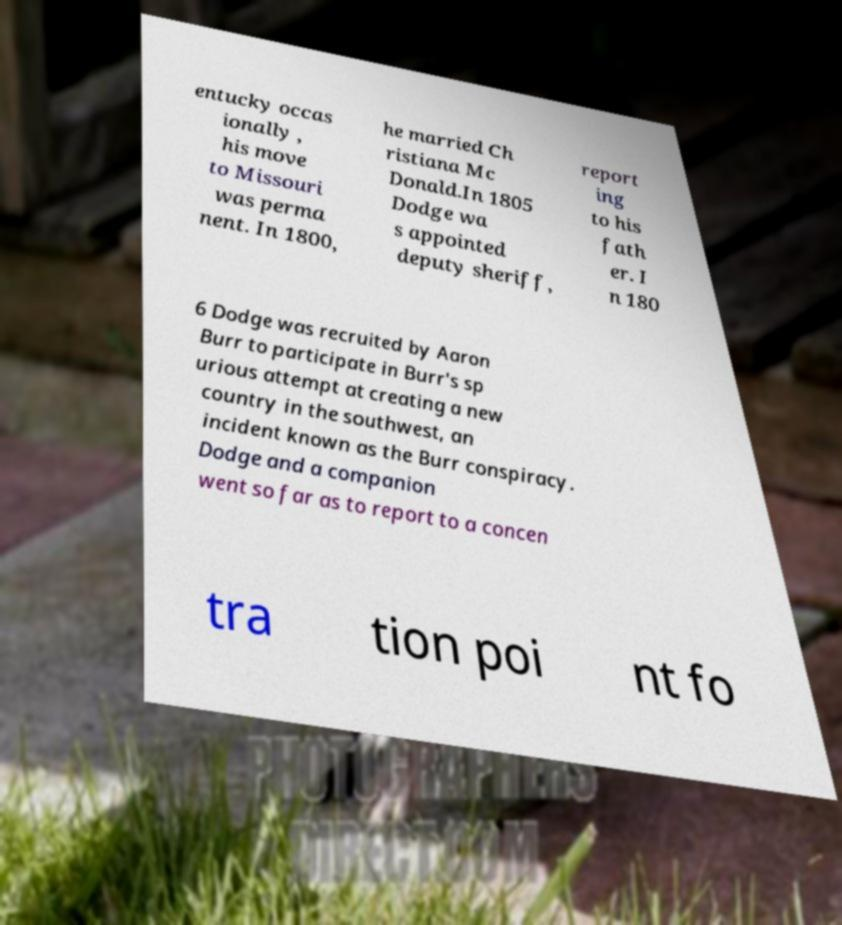Please read and relay the text visible in this image. What does it say? entucky occas ionally , his move to Missouri was perma nent. In 1800, he married Ch ristiana Mc Donald.In 1805 Dodge wa s appointed deputy sheriff, report ing to his fath er. I n 180 6 Dodge was recruited by Aaron Burr to participate in Burr's sp urious attempt at creating a new country in the southwest, an incident known as the Burr conspiracy. Dodge and a companion went so far as to report to a concen tra tion poi nt fo 